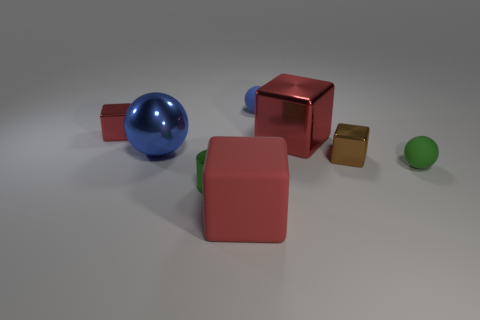What is the material of the small ball that is the same color as the small cylinder?
Your answer should be very brief. Rubber. Is the material of the big object behind the large blue sphere the same as the small ball that is behind the big red shiny thing?
Offer a terse response. No. Are any tiny rubber objects visible?
Offer a terse response. Yes. Is the number of red matte blocks that are on the left side of the tiny cylinder greater than the number of large red things right of the blue shiny sphere?
Provide a succinct answer. No. There is a tiny red object that is the same shape as the tiny brown metallic thing; what is it made of?
Your answer should be very brief. Metal. Is there anything else that has the same size as the brown block?
Your answer should be very brief. Yes. There is a thing that is in front of the tiny green cylinder; is its color the same as the tiny metal thing that is in front of the brown shiny thing?
Your answer should be very brief. No. The large red shiny thing is what shape?
Offer a very short reply. Cube. Are there more metal blocks that are behind the large blue ball than large red shiny spheres?
Your response must be concise. Yes. The small metal thing to the right of the small shiny cylinder has what shape?
Provide a short and direct response. Cube. 